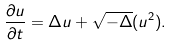Convert formula to latex. <formula><loc_0><loc_0><loc_500><loc_500>\frac { \partial u } { \partial t } = \Delta u + \sqrt { - \Delta } ( u ^ { 2 } ) .</formula> 